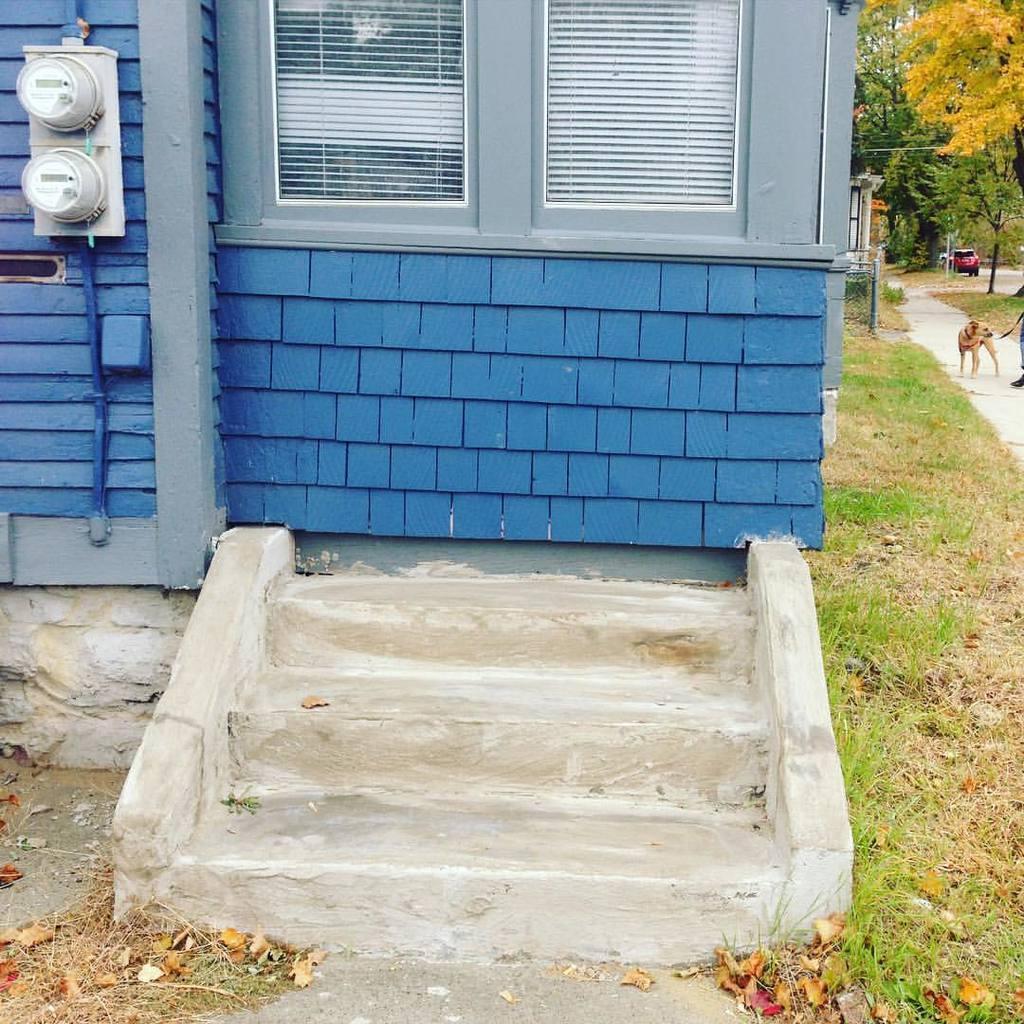Please provide a concise description of this image. In this picture there is a building in the foreground and there is staircase and there are objects on the wall. On the right side of the image there is a vehicle on the road and there is a dog and person standing on the road. At the back there are trees. At the bottom there is grass and there is a road. 